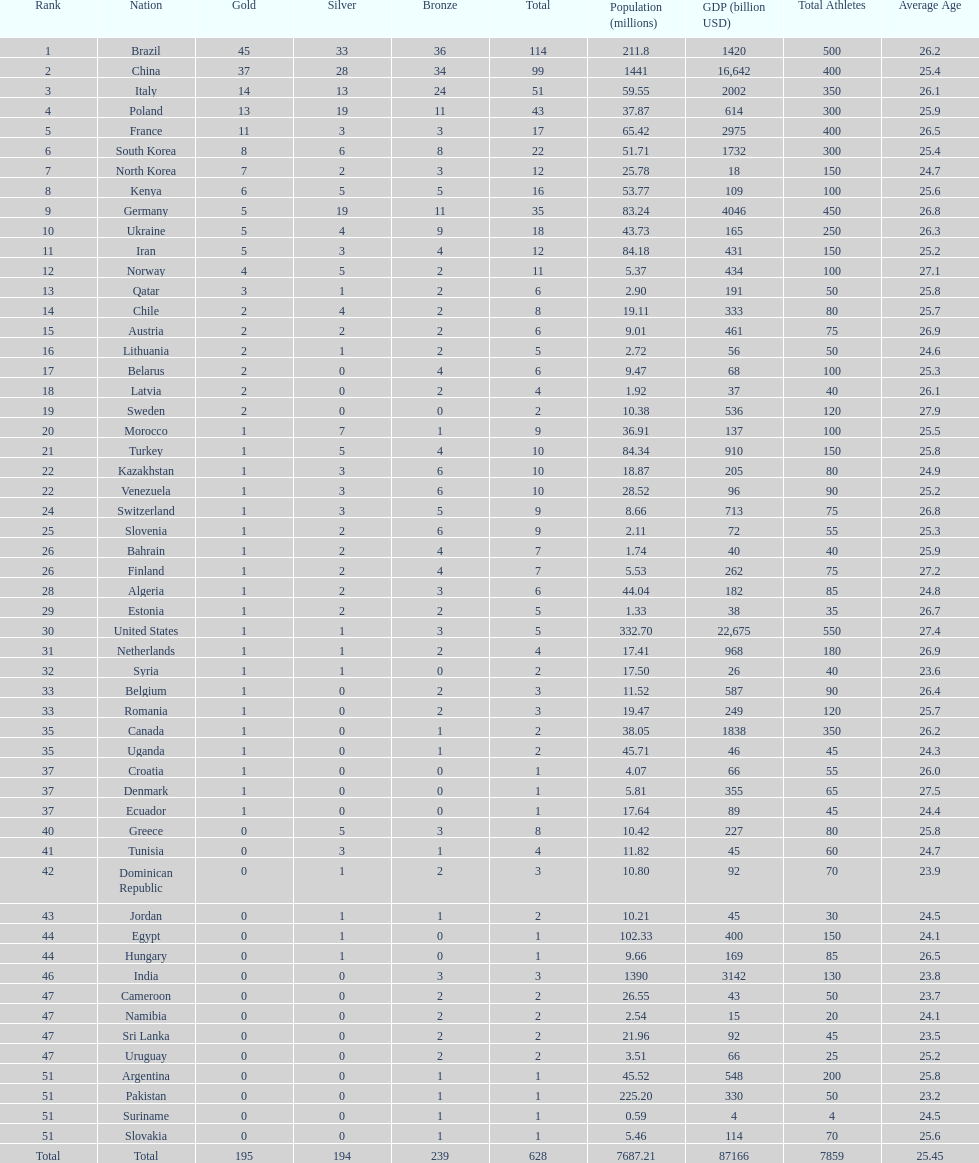Which nation earned the most gold medals? Brazil. 